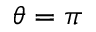<formula> <loc_0><loc_0><loc_500><loc_500>\theta = \pi</formula> 